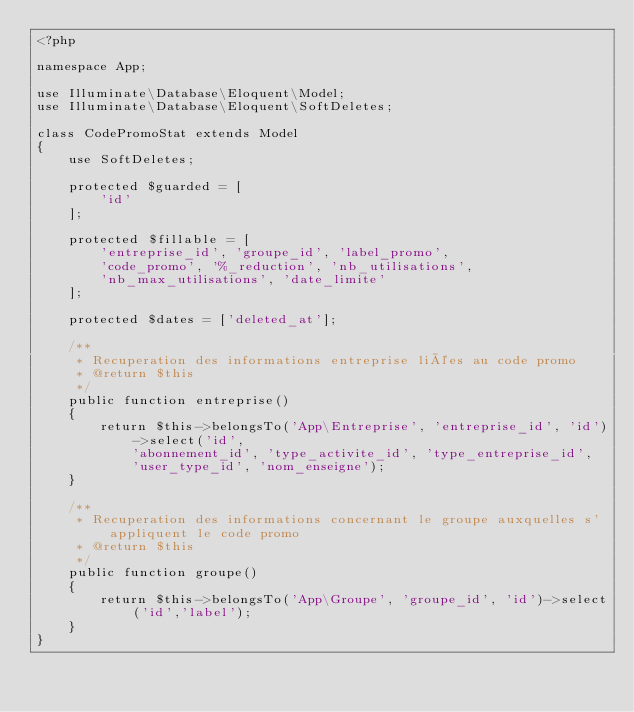<code> <loc_0><loc_0><loc_500><loc_500><_PHP_><?php

namespace App;

use Illuminate\Database\Eloquent\Model;
use Illuminate\Database\Eloquent\SoftDeletes;

class CodePromoStat extends Model
{
	use SoftDeletes;

	protected $guarded = [
        'id'
    ];

    protected $fillable = [
        'entreprise_id', 'groupe_id', 'label_promo',
        'code_promo', '%_reduction', 'nb_utilisations',
        'nb_max_utilisations', 'date_limite'
    ];

	protected $dates = ['deleted_at'];

	/**
	 * Recuperation des informations entreprise liées au code promo
	 * @return $this
	 */
	public function entreprise()
	{
		return $this->belongsTo('App\Entreprise', 'entreprise_id', 'id')->select('id',
			'abonnement_id', 'type_activite_id', 'type_entreprise_id',
			'user_type_id', 'nom_enseigne');
	}

	/**
	 * Recuperation des informations concernant le groupe auxquelles s'appliquent le code promo
	 * @return $this
	 */
	public function groupe()
	{
		return $this->belongsTo('App\Groupe', 'groupe_id', 'id')->select('id','label');
	}
}
</code> 